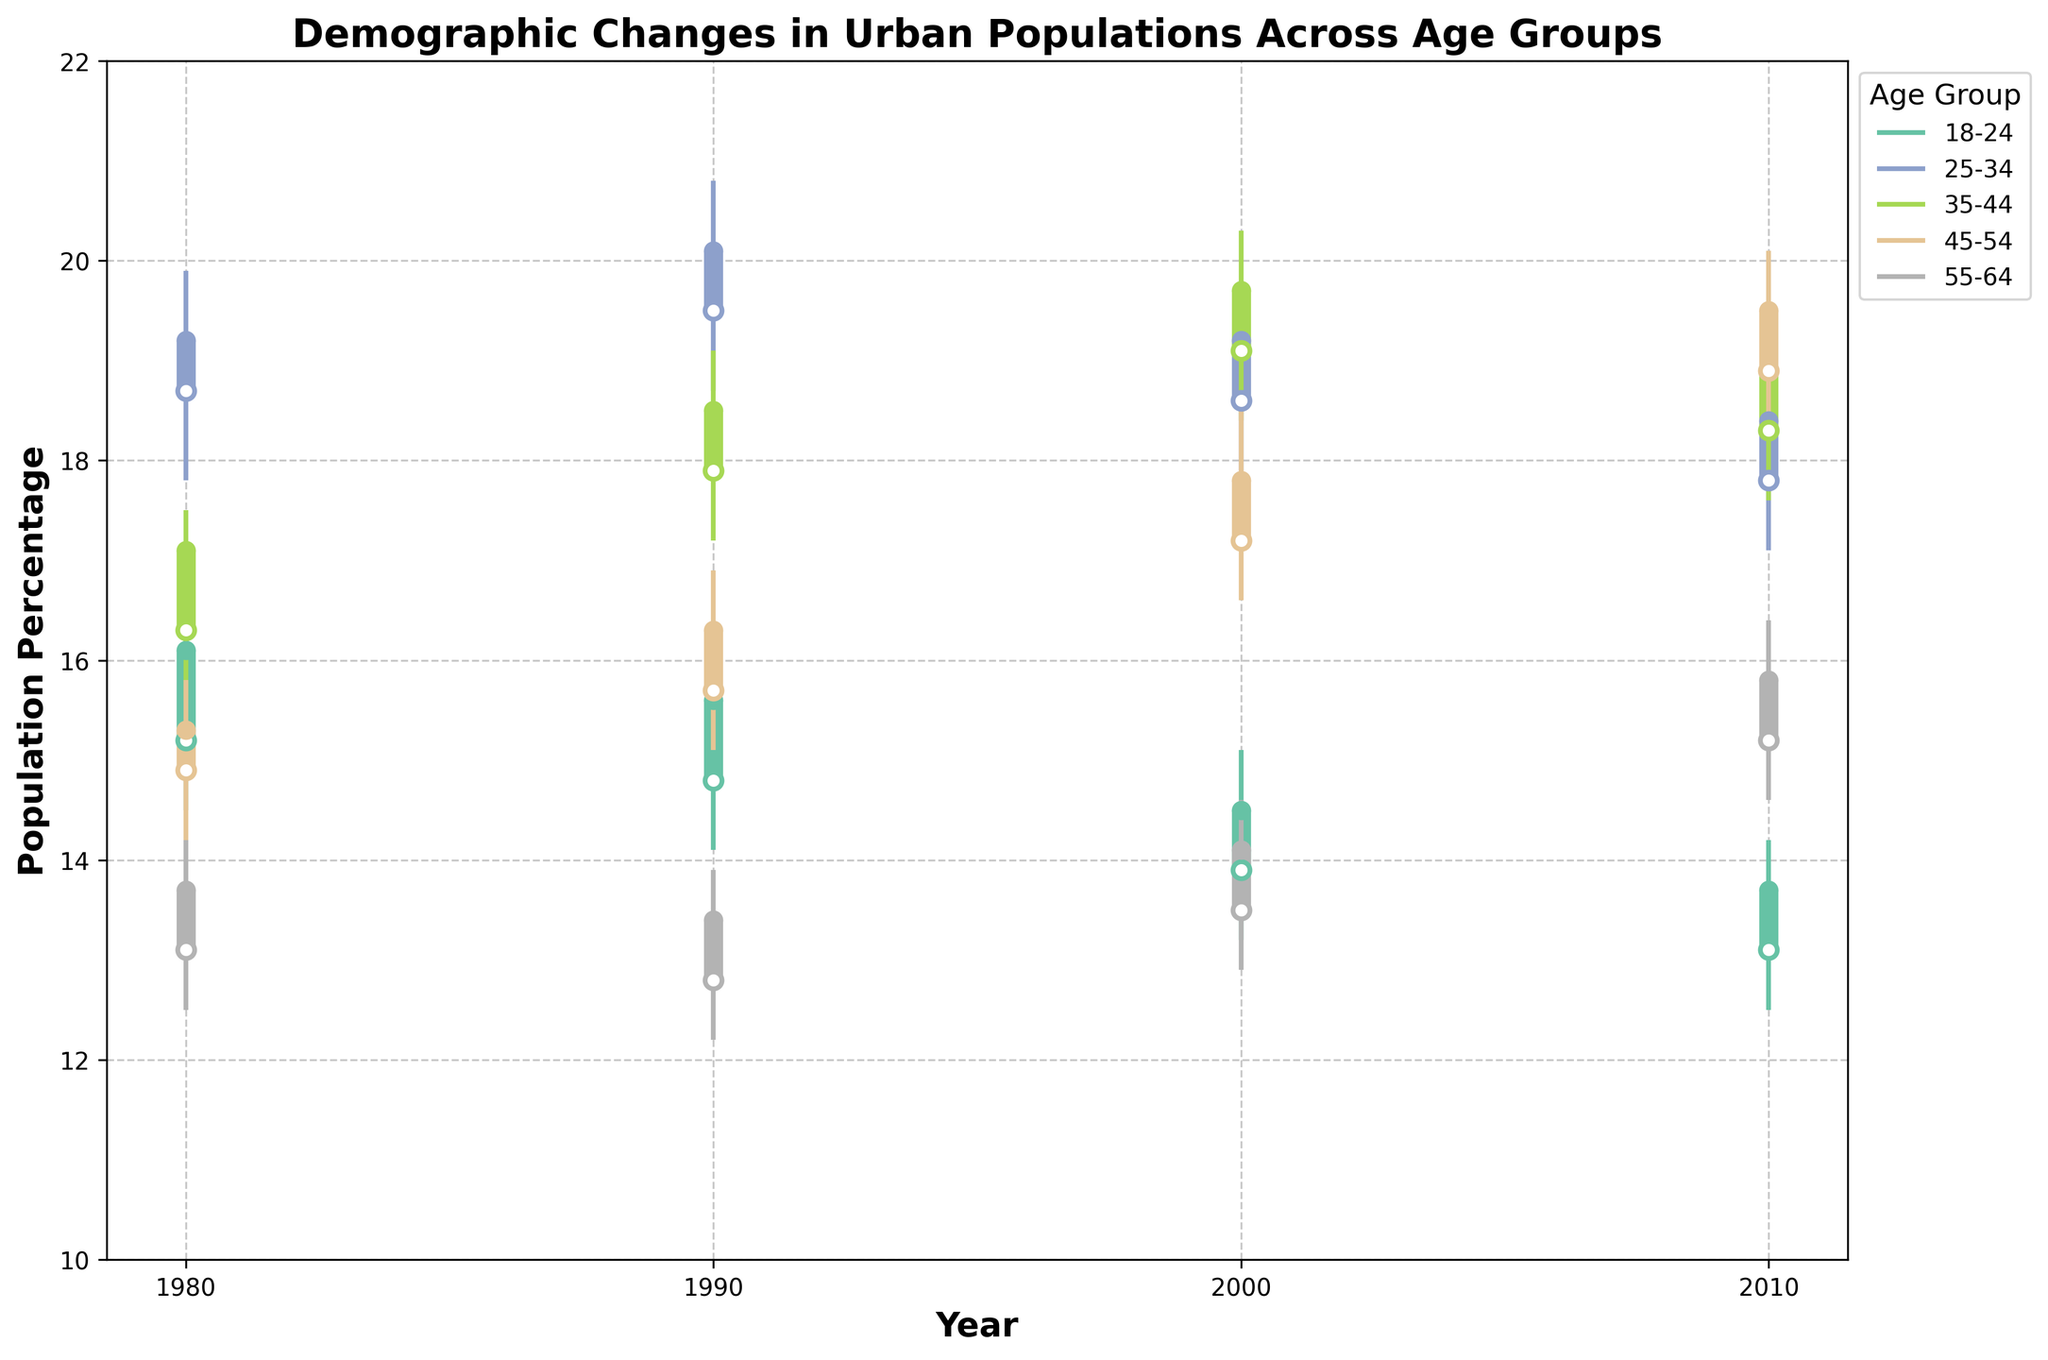What is the title of the figure? The title is usually located at the top of the figure. In this case, it is "Demographic Changes in Urban Populations Across Age Groups."
Answer: Demographic Changes in Urban Populations Across Age Groups What is the y-axis representing? The axis labels generally provide this information. Here, the y-axis is labeled "Population Percentage," so it represents the population percentage of each age group in urban areas.
Answer: Population Percentage Which age group had the highest open value in 1990? Look for the age group data for 1990 and the "Open" values. The values are 14.8 (18-24), 19.5 (25-34), 17.9 (35-44), 15.7 (45-54), and 12.8 (55-64). The highest is 19.5 for the age group 25-34.
Answer: 25-34 How did the population percentage for the 18-24 age group change from 1980 to 2010? Compare the "Close" values for the 18-24 age group in 1980 and 2010. In 1980, it was 16.1%, and in 2010, it was 13.7%. The population percentage decreased.
Answer: Decreased What is the high value of the 45-54 age group in 2010? Find the "High" value for the 45-54 age group in 2010. The value is 20.1%.
Answer: 20.1% Which age group shows the most significant increase in their close value from 1980 to 2010? Compare the "Close" values for all age groups between 1980 and 2010. The differences are: 18-24 (-2.4), 25-34 (-0.8), 35-44 (1.8), 45-54 (4.2), and 55-64 (2.1). The most significant increase is for the 45-54 age group.
Answer: 45-54 What age group had the smallest range between their high and low values in 2000? Calculate the range (High - Low) for each age group in 2000: 18-24 (15.1 - 13.2) = 1.9, 25-34 (19.8 - 17.9) = 1.9, 35-44 (20.3 - 18.4) = 1.9, 45-54 (18.5 - 16.6) = 1.9, 55-64 (14.6 - 12.9) = 1.7. The smallest range is for the 55-64 age group.
Answer: 55-64 How many distinct age groups are represented in the figure? Identify the unique age groups listed in the data. There are 5 distinct age groups: 18-24, 25-34, 35-44, 45-54, and 55-64.
Answer: 5 Which age group had a higher high value in 2000 compared to their high value in 1990? Compare the "High" values in 2000 and 1990 for each age group. Ages 18-24: 15.1 (2000) vs. 16.2 (1990), 25-34: 19.8 (2000) vs. 20.8 (1990), 35-44: 20.3 (2000) vs. 19.1 (1990), 45-54: 18.5 (2000) vs. 16.9 (1990), 55-64: 14.6 (2000) vs. 13.9 (1990). The age groups 35-44, 45-54, and 55-64 had higher high values in 2000 than in 1990.
Answer: 35-44, 45-54, 55-64 